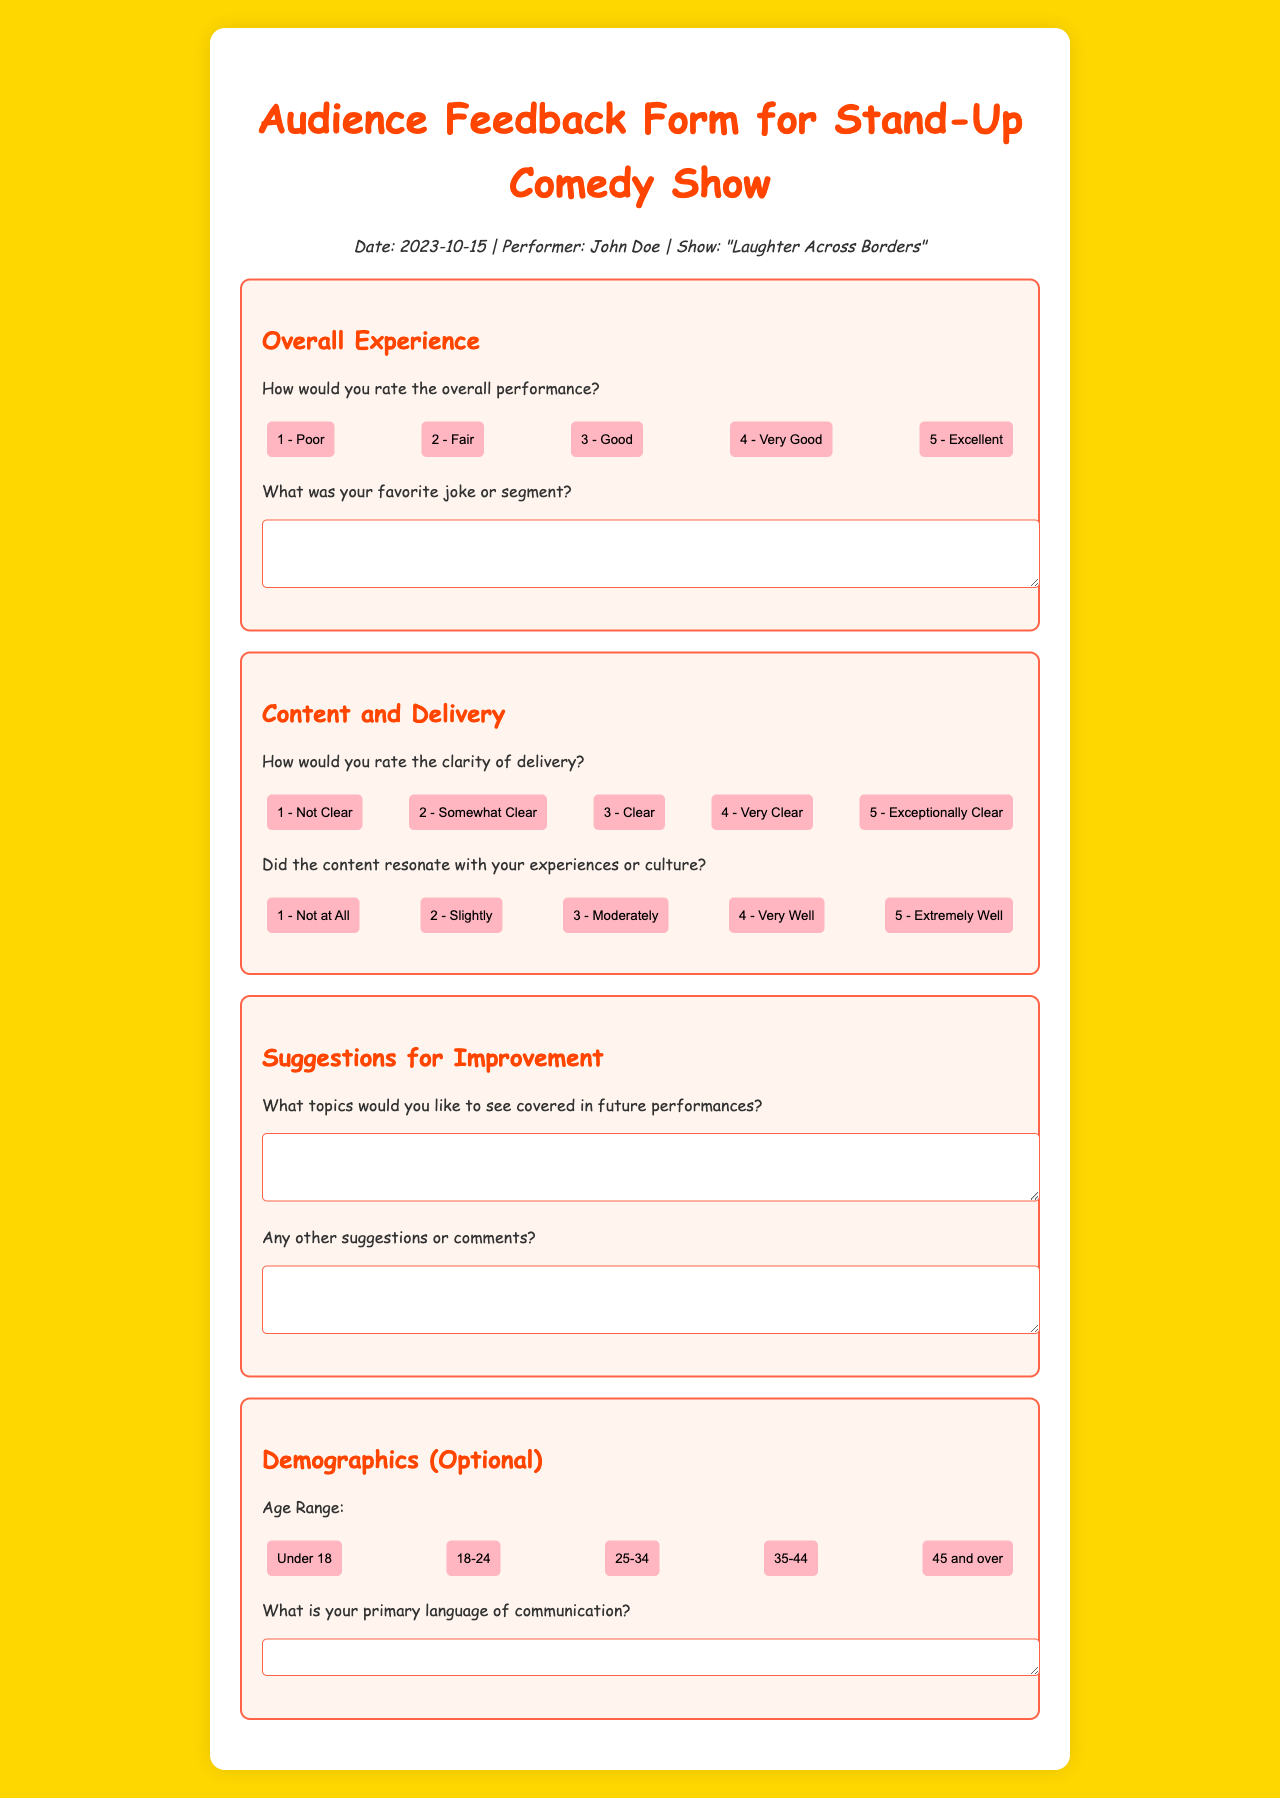What is the title of the performance? The title of the performance is mentioned in the document under the show info section.
Answer: "Laughter Across Borders" Who is the performer? The performer's name is listed in the show information section of the document.
Answer: John Doe What date was the comedy show held? The date of the show is provided in the show info section, specifying when it took place.
Answer: 2023-10-15 How many rating options are provided for the overall performance? The document lists the buttons provided for rating the overall performance, which can be counted.
Answer: 5 What is the highest rating for clarity of delivery? The document indicates the top rating option available for clarity of delivery.
Answer: 5 - Exceptionally Clear What section asks for feedback about topics for future performances? The document contains a specific section dedicated to improvement suggestions where feedback is requested.
Answer: Suggestions for Improvement What is stated as the optional demographic question regarding age range? The document includes an optional question regarding demographic data, specifying different age categories.
Answer: Age Range Which color is used for the background of the document? The main background color used for the body of the document is specified within the style section.
Answer: #FFD700 What is the primary language question asking for? The document requests information regarding the preferred primary language, which is included in the demographics section.
Answer: Primary language of communication 